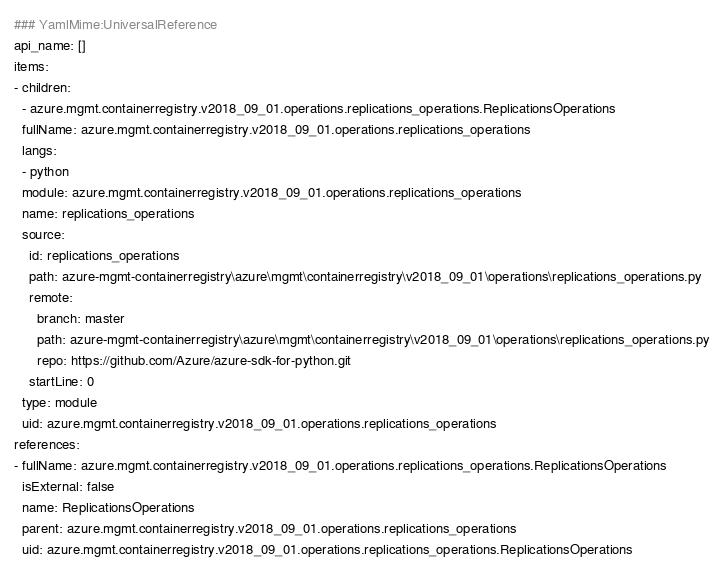<code> <loc_0><loc_0><loc_500><loc_500><_YAML_>### YamlMime:UniversalReference
api_name: []
items:
- children:
  - azure.mgmt.containerregistry.v2018_09_01.operations.replications_operations.ReplicationsOperations
  fullName: azure.mgmt.containerregistry.v2018_09_01.operations.replications_operations
  langs:
  - python
  module: azure.mgmt.containerregistry.v2018_09_01.operations.replications_operations
  name: replications_operations
  source:
    id: replications_operations
    path: azure-mgmt-containerregistry\azure\mgmt\containerregistry\v2018_09_01\operations\replications_operations.py
    remote:
      branch: master
      path: azure-mgmt-containerregistry\azure\mgmt\containerregistry\v2018_09_01\operations\replications_operations.py
      repo: https://github.com/Azure/azure-sdk-for-python.git
    startLine: 0
  type: module
  uid: azure.mgmt.containerregistry.v2018_09_01.operations.replications_operations
references:
- fullName: azure.mgmt.containerregistry.v2018_09_01.operations.replications_operations.ReplicationsOperations
  isExternal: false
  name: ReplicationsOperations
  parent: azure.mgmt.containerregistry.v2018_09_01.operations.replications_operations
  uid: azure.mgmt.containerregistry.v2018_09_01.operations.replications_operations.ReplicationsOperations
</code> 